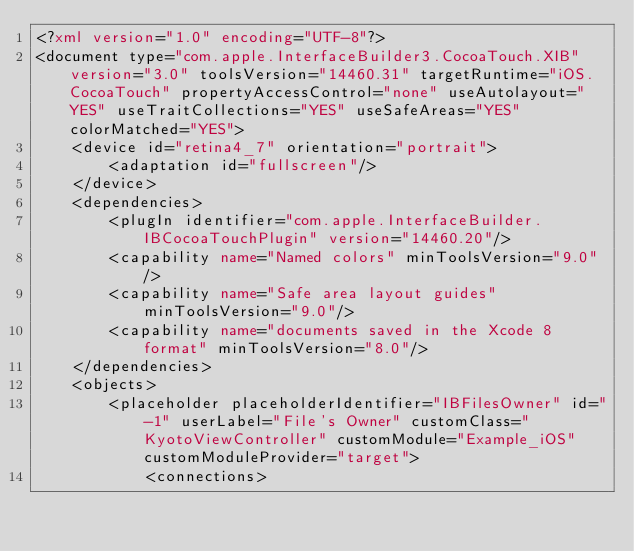Convert code to text. <code><loc_0><loc_0><loc_500><loc_500><_XML_><?xml version="1.0" encoding="UTF-8"?>
<document type="com.apple.InterfaceBuilder3.CocoaTouch.XIB" version="3.0" toolsVersion="14460.31" targetRuntime="iOS.CocoaTouch" propertyAccessControl="none" useAutolayout="YES" useTraitCollections="YES" useSafeAreas="YES" colorMatched="YES">
    <device id="retina4_7" orientation="portrait">
        <adaptation id="fullscreen"/>
    </device>
    <dependencies>
        <plugIn identifier="com.apple.InterfaceBuilder.IBCocoaTouchPlugin" version="14460.20"/>
        <capability name="Named colors" minToolsVersion="9.0"/>
        <capability name="Safe area layout guides" minToolsVersion="9.0"/>
        <capability name="documents saved in the Xcode 8 format" minToolsVersion="8.0"/>
    </dependencies>
    <objects>
        <placeholder placeholderIdentifier="IBFilesOwner" id="-1" userLabel="File's Owner" customClass="KyotoViewController" customModule="Example_iOS" customModuleProvider="target">
            <connections></code> 